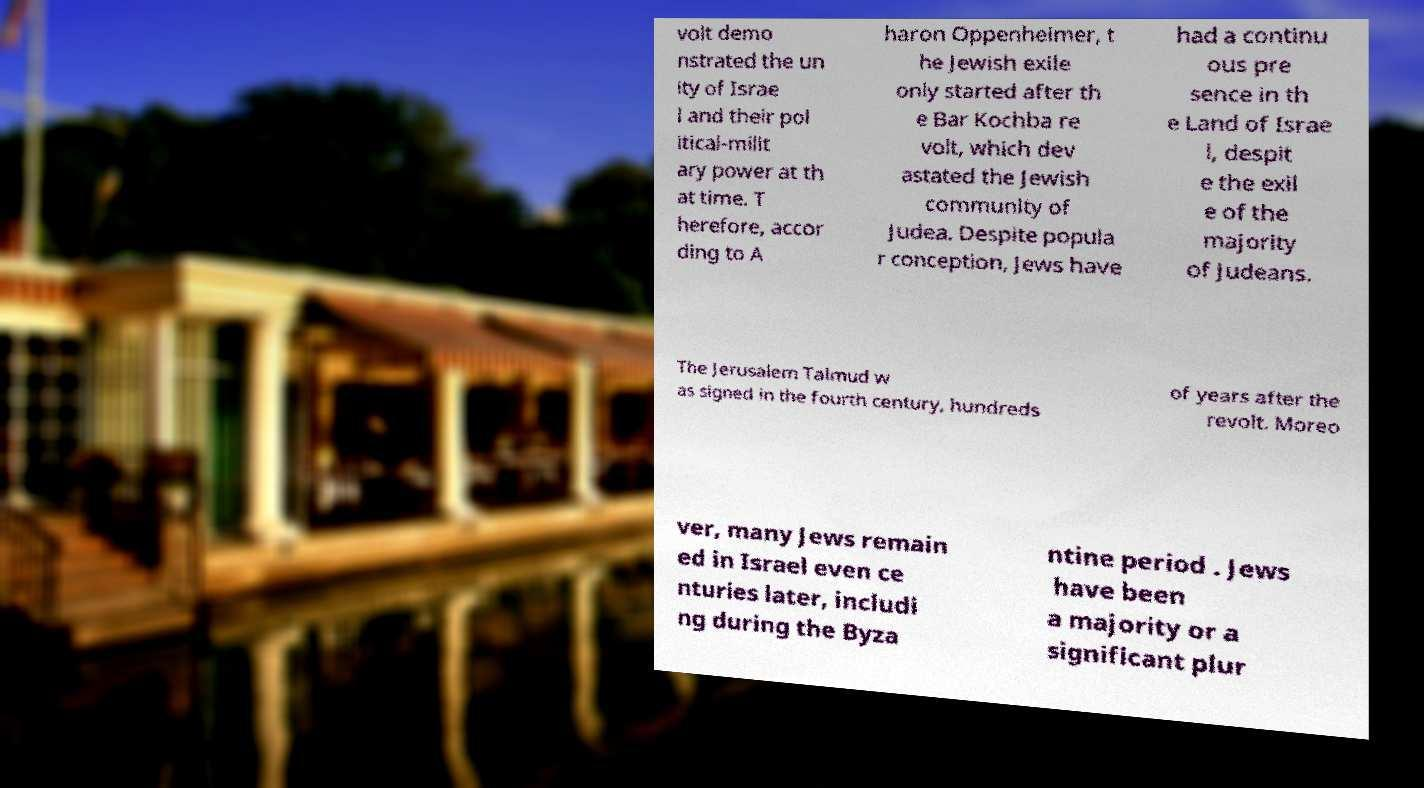Please read and relay the text visible in this image. What does it say? volt demo nstrated the un ity of Israe l and their pol itical-milit ary power at th at time. T herefore, accor ding to A haron Oppenheimer, t he Jewish exile only started after th e Bar Kochba re volt, which dev astated the Jewish community of Judea. Despite popula r conception, Jews have had a continu ous pre sence in th e Land of Israe l, despit e the exil e of the majority of Judeans. The Jerusalem Talmud w as signed in the fourth century, hundreds of years after the revolt. Moreo ver, many Jews remain ed in Israel even ce nturies later, includi ng during the Byza ntine period . Jews have been a majority or a significant plur 